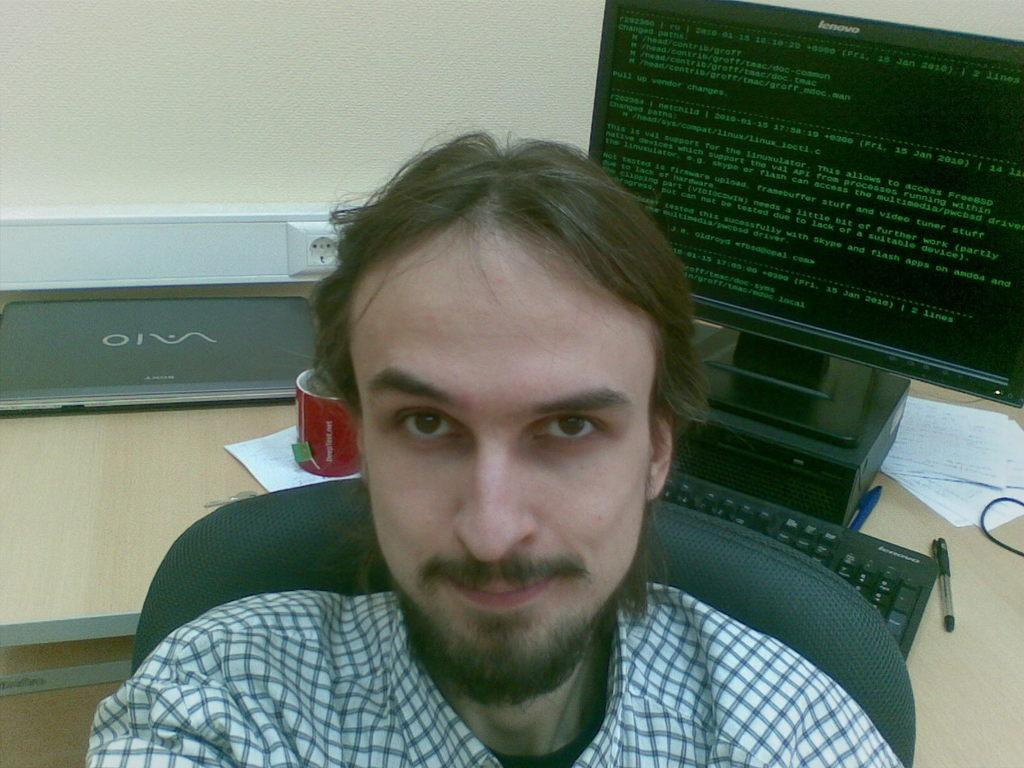What is the person in the image doing? The person is sitting in the chair. What can be seen in the background of the image? There is a computer, a keyboard, and a coffee cup in the backdrop. What type of monkey is sitting on the person's lap in the image? There is no monkey present in the image; the person is sitting alone in the chair. 